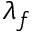<formula> <loc_0><loc_0><loc_500><loc_500>\lambda _ { f }</formula> 